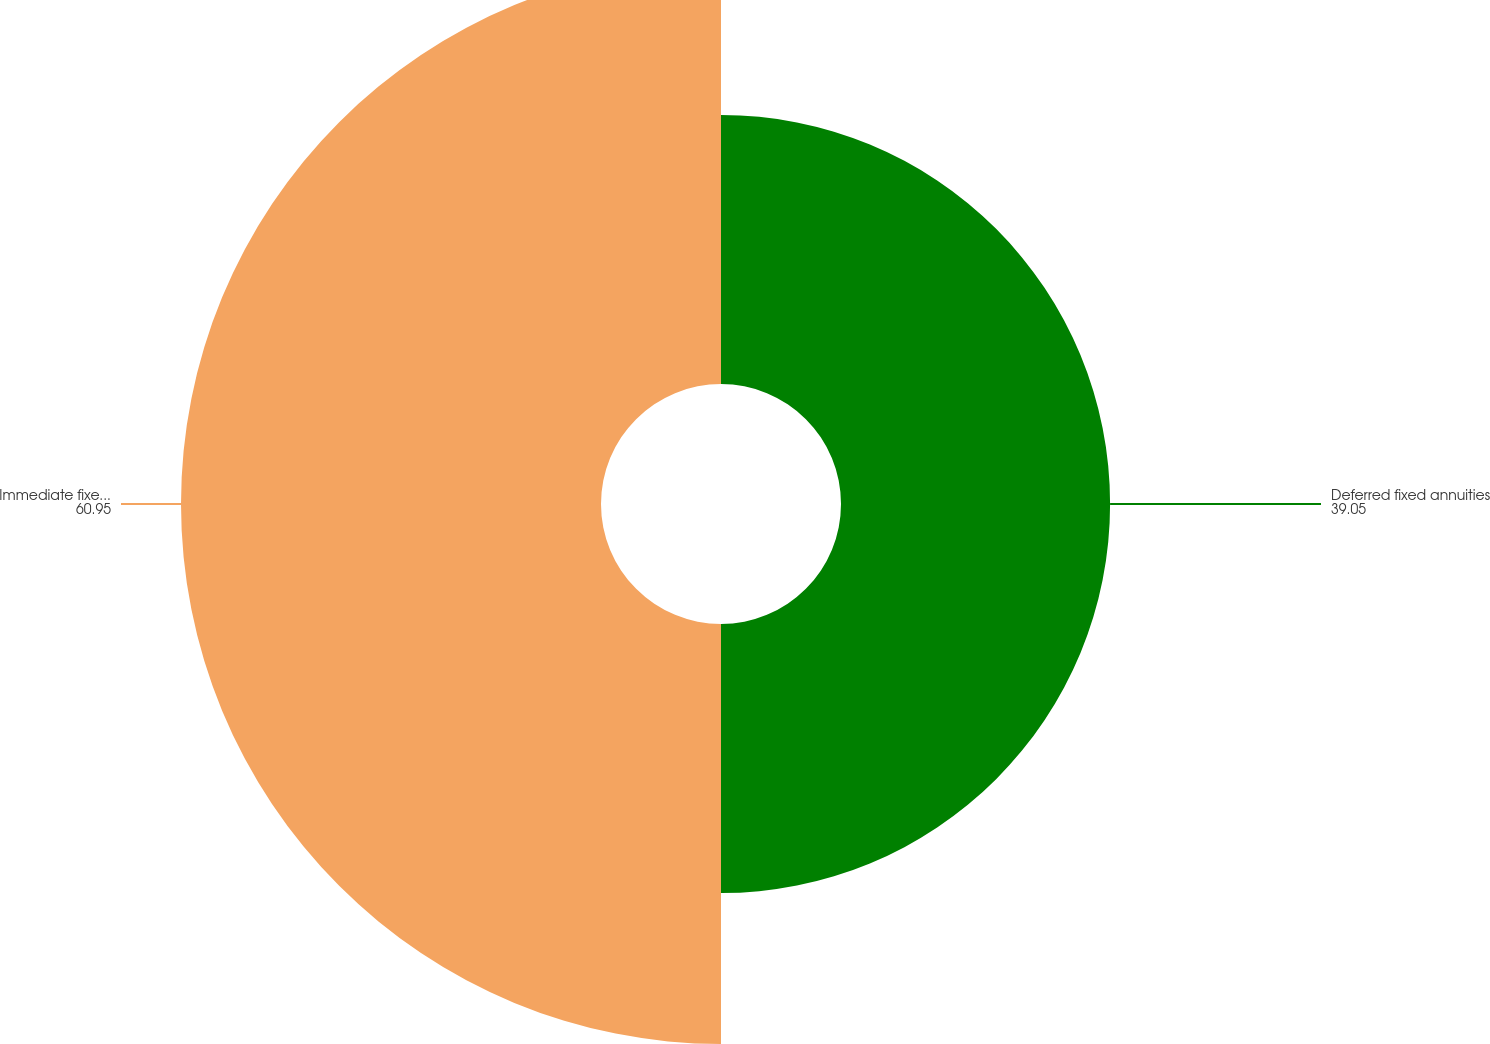Convert chart. <chart><loc_0><loc_0><loc_500><loc_500><pie_chart><fcel>Deferred fixed annuities<fcel>Immediate fixed annuities with<nl><fcel>39.05%<fcel>60.95%<nl></chart> 